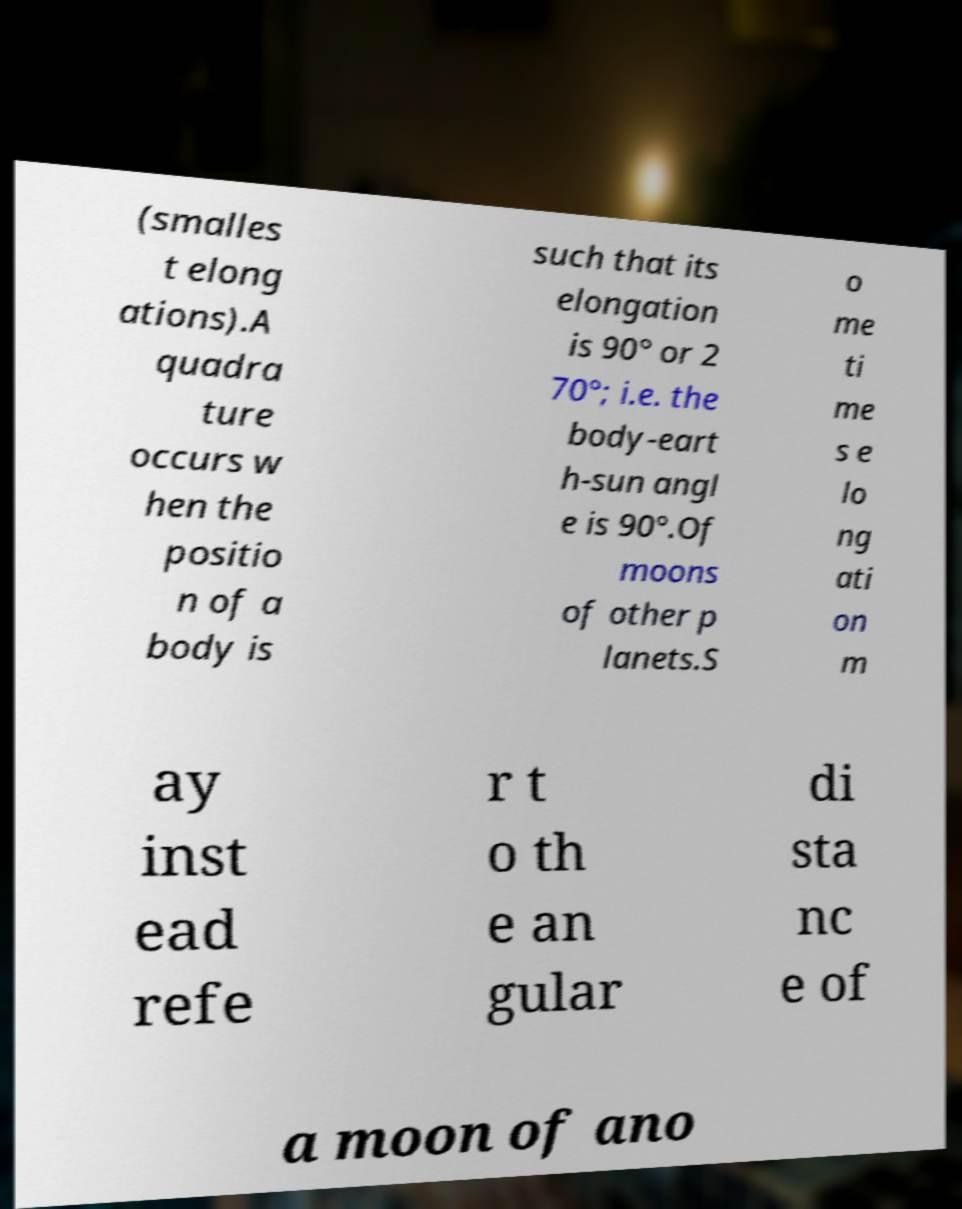There's text embedded in this image that I need extracted. Can you transcribe it verbatim? (smalles t elong ations).A quadra ture occurs w hen the positio n of a body is such that its elongation is 90° or 2 70°; i.e. the body-eart h-sun angl e is 90°.Of moons of other p lanets.S o me ti me s e lo ng ati on m ay inst ead refe r t o th e an gular di sta nc e of a moon of ano 